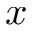<formula> <loc_0><loc_0><loc_500><loc_500>x</formula> 